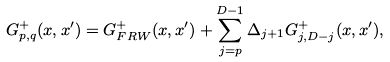<formula> <loc_0><loc_0><loc_500><loc_500>G _ { p , q } ^ { + } ( x , x ^ { \prime } ) = G _ { F R W } ^ { + } ( x , x ^ { \prime } ) + \sum _ { j = p } ^ { D - 1 } \Delta _ { j + 1 } G _ { j , D - j } ^ { + } ( x , x ^ { \prime } ) ,</formula> 